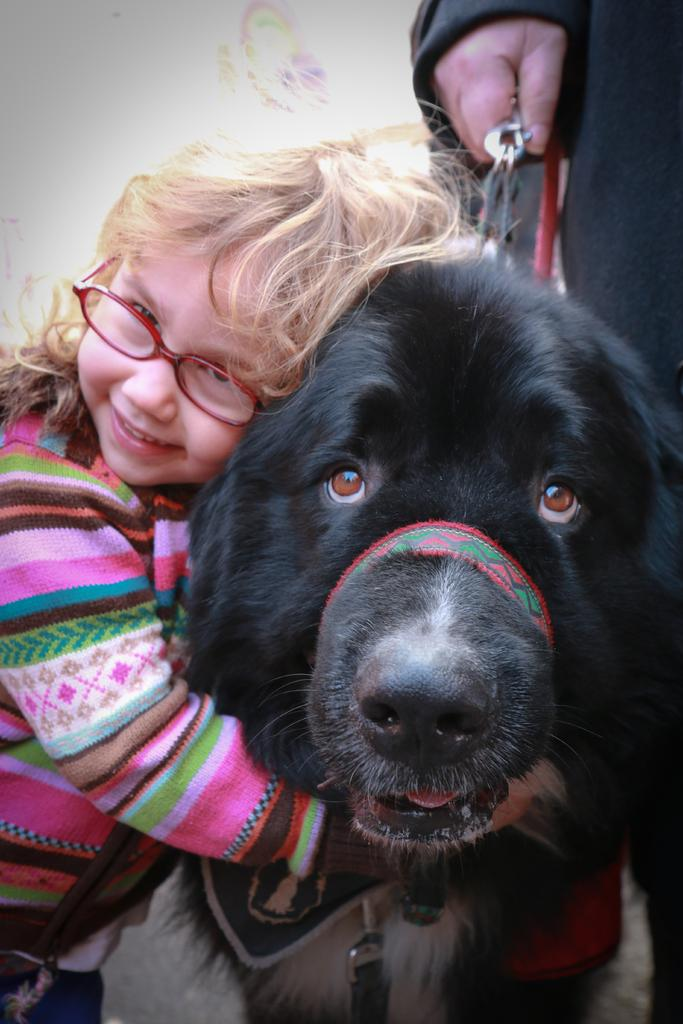What is the main subject of the image? There is a baby in the image. What is the baby doing in the image? The baby is standing in the image. What other living creature is present in the image? There is a dog in the image. How is the dog positioned in relation to the baby? The dog is beside the baby in the image. Who else is in the image? There is a person in the image. What is the person doing with the dog? The person is holding the dog's belt in the image. What type of rock can be seen in the image? There is no rock present in the image. How many geese are flying in the image? There are no geese present in the image. 